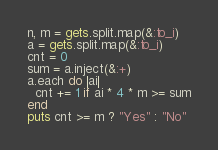<code> <loc_0><loc_0><loc_500><loc_500><_Ruby_>n, m = gets.split.map(&:to_i)
a = gets.split.map(&:to_i)
cnt = 0
sum = a.inject(&:+)
a.each do |ai|
  cnt += 1 if ai * 4 * m >= sum
end
puts cnt >= m ? "Yes" : "No"
</code> 